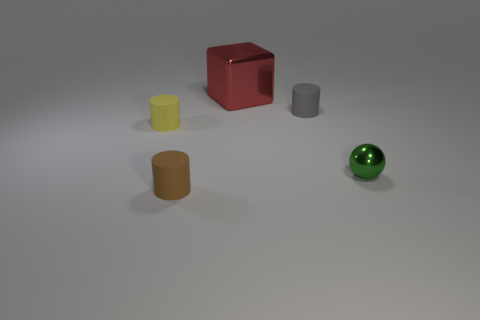How does the lighting in the image affect the mood or atmosphere? The lighting in the image creates soft shadows and subtle highlights, giving the scene a calm and neutral atmosphere. There's a gentle gradient of light that suggests a tranquil, nondescript environment, which does not evoke any strong emotional response, keeping the focus on the shapes and colors of the objects. 